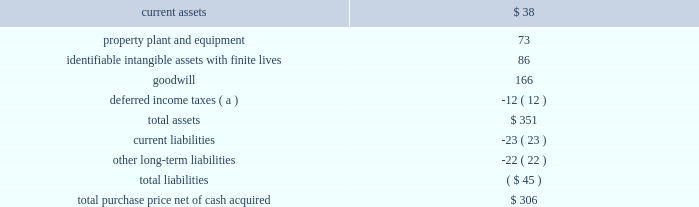58 2018 ppg annual report and 10-k the crown group on october 2 , 2017 , ppg acquired the crown group ( 201ccrown 201d ) , a u.s.-based coatings application services business , which is reported as part of ppg's industrial coatings reportable segment .
Crown is one of the leading component and product finishers in north america .
Crown applies coatings to customers 2019 manufactured parts and assembled products at 11 u.s .
Sites .
Most of crown 2019s facilities , which also provide assembly , warehousing and sequencing services , are located at customer facilities or positioned near customer manufacturing sites .
The company serves manufacturers in the automotive , agriculture , construction , heavy truck and alternative energy industries .
The pro-forma impact on ppg's sales and results of operations , including the pro forma effect of events that are directly attributable to the acquisition , was not significant .
The results of this business since the date of acquisition have been reported within the industrial coatings business within the industrial coatings reportable segment .
Taiwan chlorine industries taiwan chlorine industries ( 201ctci 201d ) was established in 1986 as a joint venture between ppg and china petrochemical development corporation ( 201ccpdc 201d ) to produce chlorine-based products in taiwan , at which time ppg owned 60 percent of the venture .
In conjunction with the 2013 separation of its commodity chemicals business , ppg conveyed to axiall corporation ( "axiall" ) its 60% ( 60 % ) ownership interest in tci .
Under ppg 2019s agreement with cpdc , if certain post-closing conditions were not met following the three year anniversary of the separation , cpdc had the option to sell its 40% ( 40 % ) ownership interest in tci to axiall for $ 100 million .
In turn , axiall had a right to designate ppg as its designee to purchase the 40% ( 40 % ) ownership interest of cpdc .
In april 2016 , axiall announced that cpdc had decided to sell its ownership interest in tci to axiall .
In june 2016 , axiall formally designated ppg to purchase the 40% ( 40 % ) ownership interest in tci .
In august 2016 , westlake chemical corporation acquired axiall , which became a wholly-owned subsidiary of westlake .
In april 2017 , ppg finalized its purchase of cpdc 2019s 40% ( 40 % ) ownership interest in tci .
The difference between the acquisition date fair value and the purchase price of ppg 2019s 40% ( 40 % ) ownership interest in tci has been recorded as a loss in discontinued operations during the year-ended december 31 , 2017 .
Ppg 2019s ownership in tci is accounted for as an equity method investment and the related equity earnings are reported within other income in the consolidated statement of income and in legacy in note 20 , 201creportable business segment information . 201d metokote corporation in july 2016 , ppg completed the acquisition of metokote corporation ( "metokote" ) , a u.s.-based coatings application services business .
Metokote applies coatings to customers' manufactured parts and assembled products .
It operates on- site coatings services within several customer manufacturing locations , as well as at regional service centers , located throughout the u.s. , canada , mexico , the united kingdom , germany , hungary and the czech republic .
Customers ship parts to metokote ae service centers where they are treated to enhance paint adhesion and painted with electrocoat , powder or liquid coatings technologies .
Coated parts are then shipped to the customer 2019s next stage of assembly .
Metokote coats an average of more than 1.5 million parts per day .
The table summarizes the estimated fair value of assets acquired and liabilities assumed as reflected in the final purchase price allocation for metokote .
( $ in millions ) .
( a ) the net deferred income tax liability is included in assets due to the company's tax jurisdictional netting .
The pro-forma impact on ppg's sales and results of operations , including the pro forma effect of events that are directly attributable to the acquisition , was not significant .
While calculating this impact , no cost savings or operating synergies that may result from the acquisition were included .
The results of this business since the date of acquisition have been reported within the industrial coatings business within the industrial coatings reportable segment .
Notes to the consolidated financial statements .
What percent of the total purchase price net of cash acquired was goodwill? 
Computations: (166 / 306)
Answer: 0.54248. 